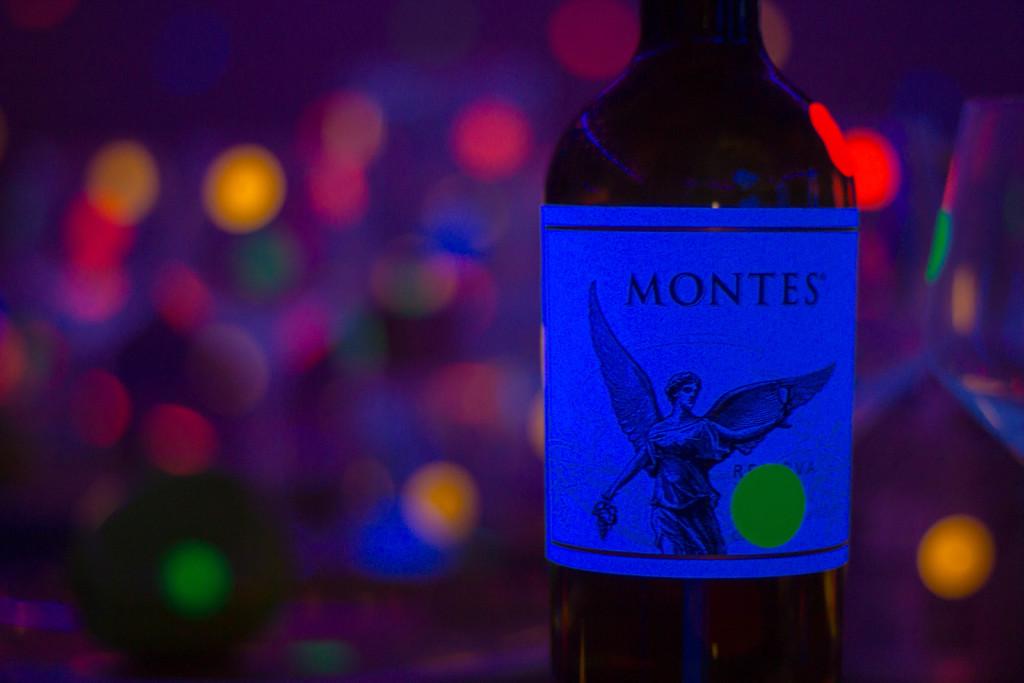What brand is that?
Provide a short and direct response. Montes. 